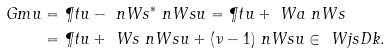Convert formula to latex. <formula><loc_0><loc_0><loc_500><loc_500>\ G m u & = \P t u - \ n W s ^ { * } \ n W s u = \P t u + \ W a \ n W s \\ & = \P t u + \ W s \ n W s u + ( \nu - 1 ) \ n W s u \in \ W j s D { k } .</formula> 